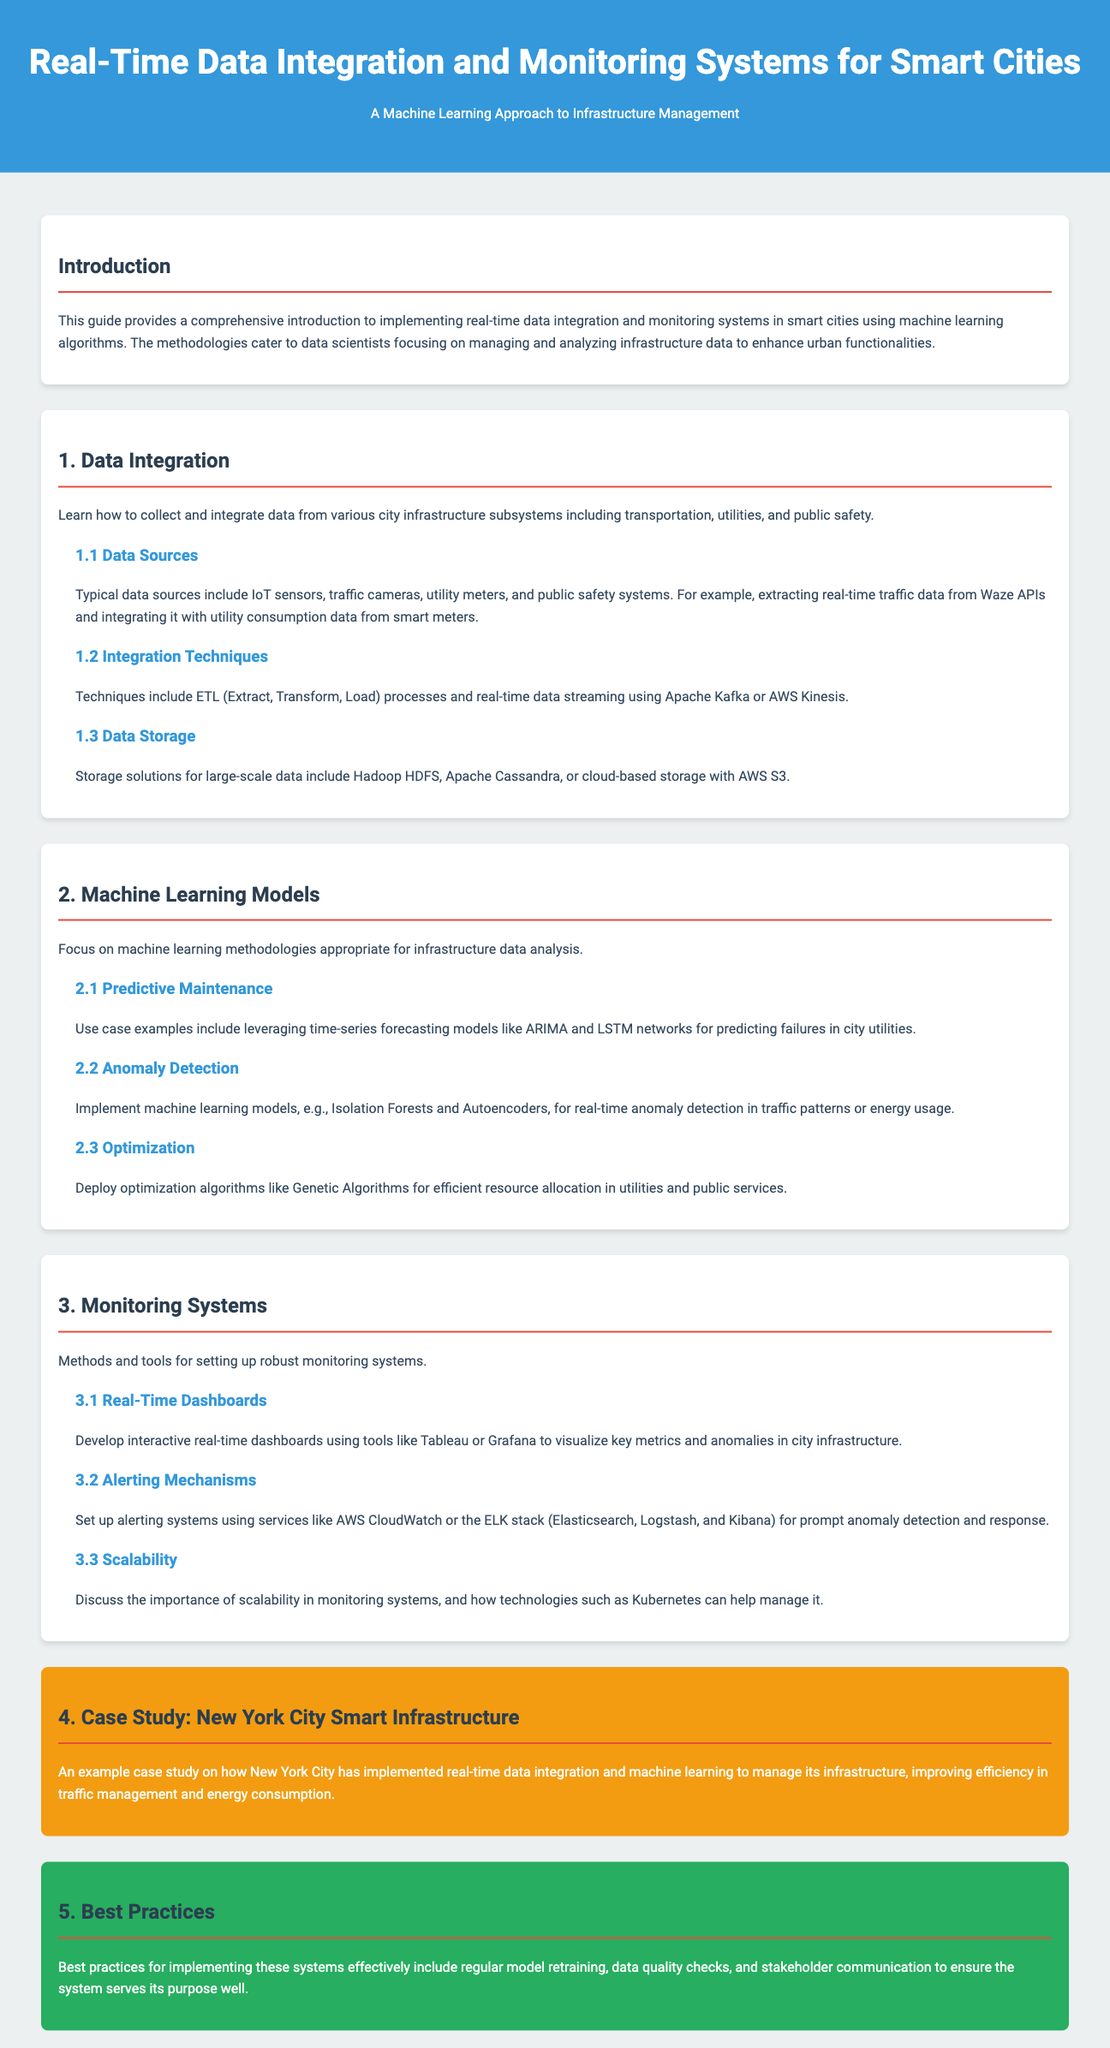What is the title of the guide? The title of the guide is presented at the top of the document as the main heading.
Answer: Real-Time Data Integration and Monitoring Systems for Smart Cities What section discusses data sources? The section that discusses data sources is a subsection under the Data Integration section.
Answer: 1.1 Data Sources Which cloud storage service is mentioned? The document lists various storage solutions, including a specific cloud service.
Answer: AWS S3 What is a machine learning model used for predictive maintenance? The document provides an example of a specific model used for predictive maintenance in city utilities.
Answer: ARIMA What tool is suggested for real-time dashboards? The guide recommends specific tools for creating real-time dashboards in the Monitoring Systems section.
Answer: Tableau How many case studies are presented in the guide? The guide presents only one case study, as indicated in the sections.
Answer: 1 What best practice involves regular model updates? The best practices section discusses an important practice regarding model updates among several others.
Answer: Regular model retraining What technique is employed for real-time anomaly detection? The document details specific techniques suitable for real-time anomaly detection in traffic patterns or energy usage.
Answer: Isolation Forests 